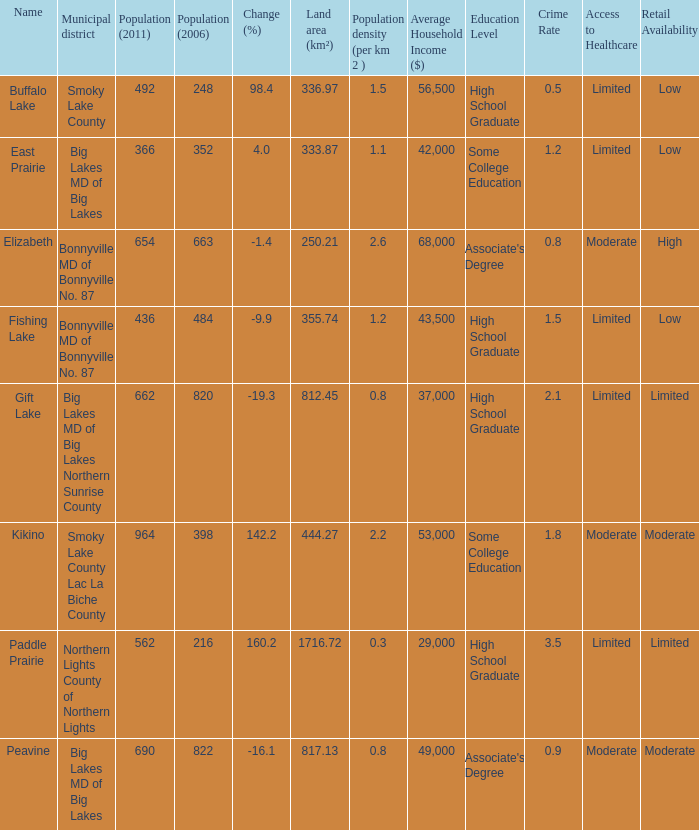What place is there a change of -19.3? 1.0. 